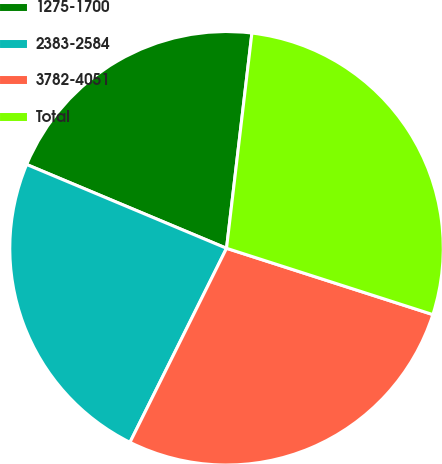<chart> <loc_0><loc_0><loc_500><loc_500><pie_chart><fcel>1275-1700<fcel>2383-2584<fcel>3782-4051<fcel>Total<nl><fcel>20.55%<fcel>23.97%<fcel>27.4%<fcel>28.08%<nl></chart> 